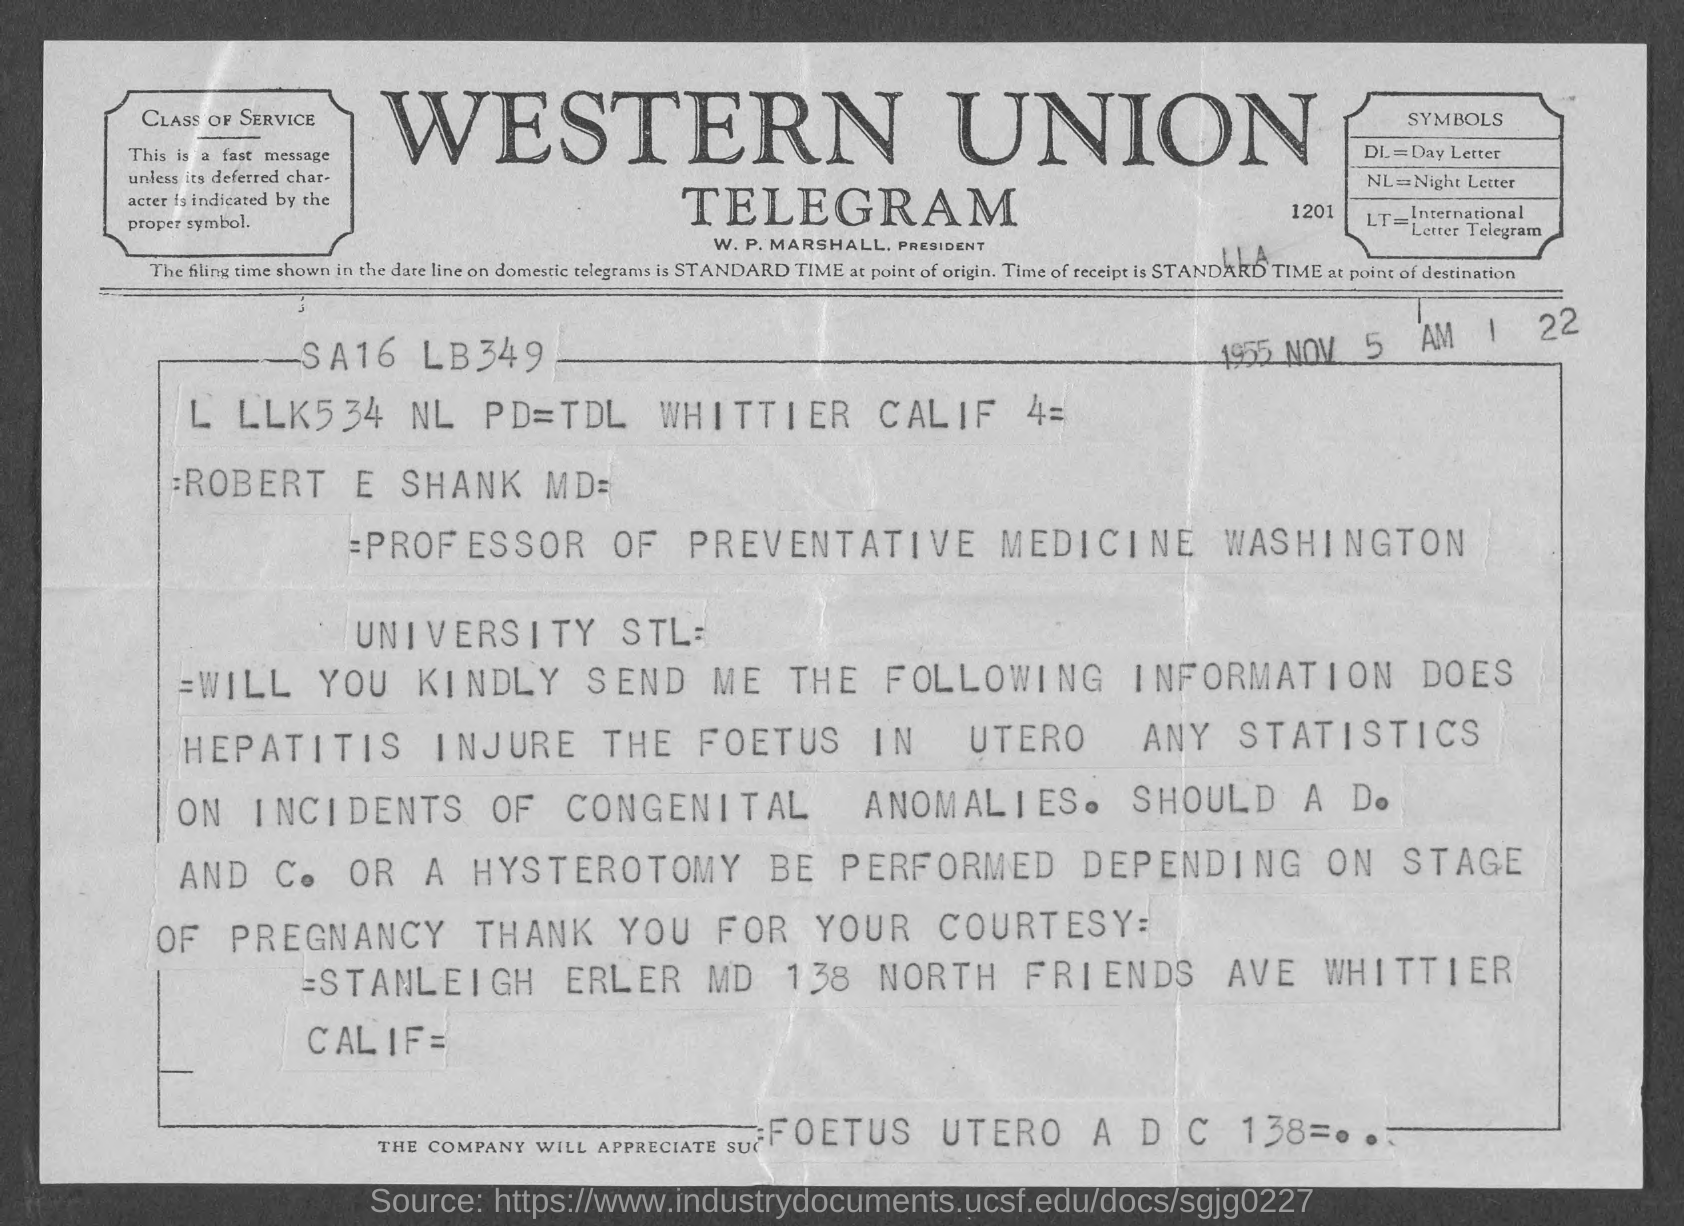Give some essential details in this illustration. DL stands for the day letter, which is a way of labeling days in a schedule using letters of the alphabet. William P. Marshall is the President. Night letter" refers to a type of letter that was sent through the mail during the nighttime hours, typically between the hours of 10:00 PM and 6:00 AM. LT stands for International Letter Telegram. 